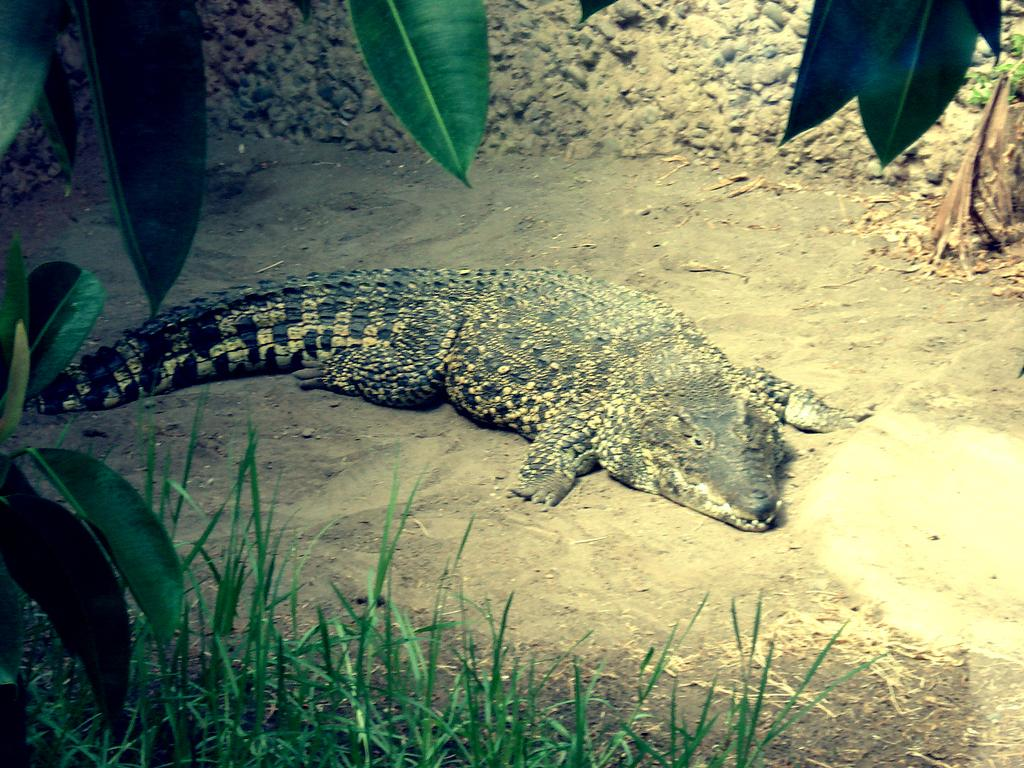What animal is on the ground in the image? There is a crocodile on the ground in the image. What type of vegetation is present in the image? Grass is present in the image, and leaves are also visible. What can be seen in the background of the image? There is a wall in the background of the image. What type of nut is being cracked by the kitten in the image? There is no kitten or nut present in the image; it features a crocodile on the ground. 